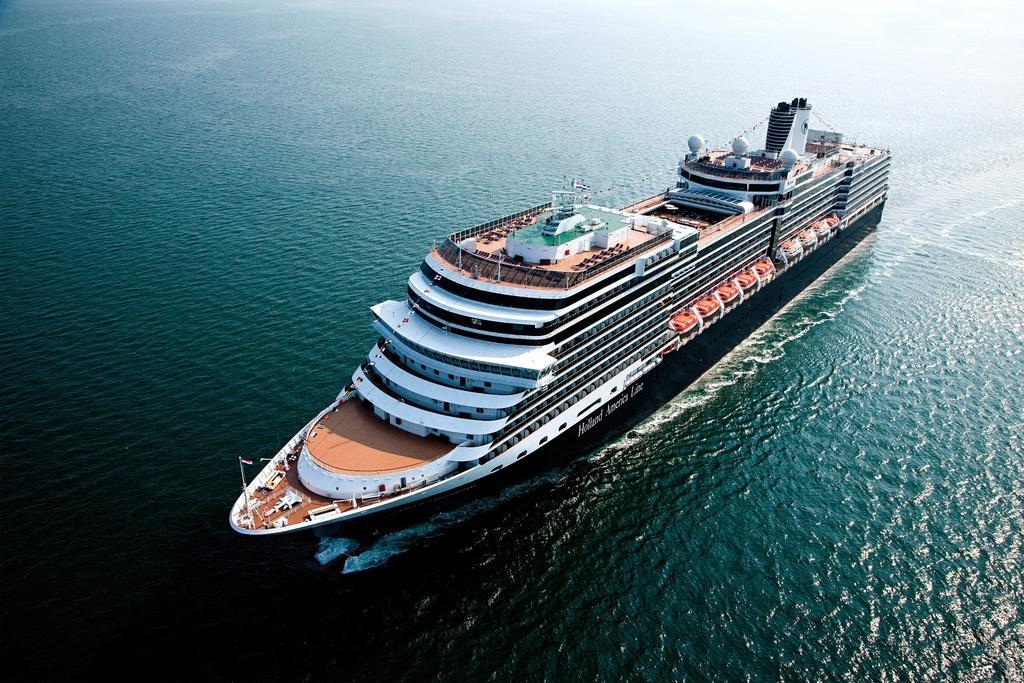Please provide a concise description of this image. In this picture we can see a ship on the water with some objects on it. 